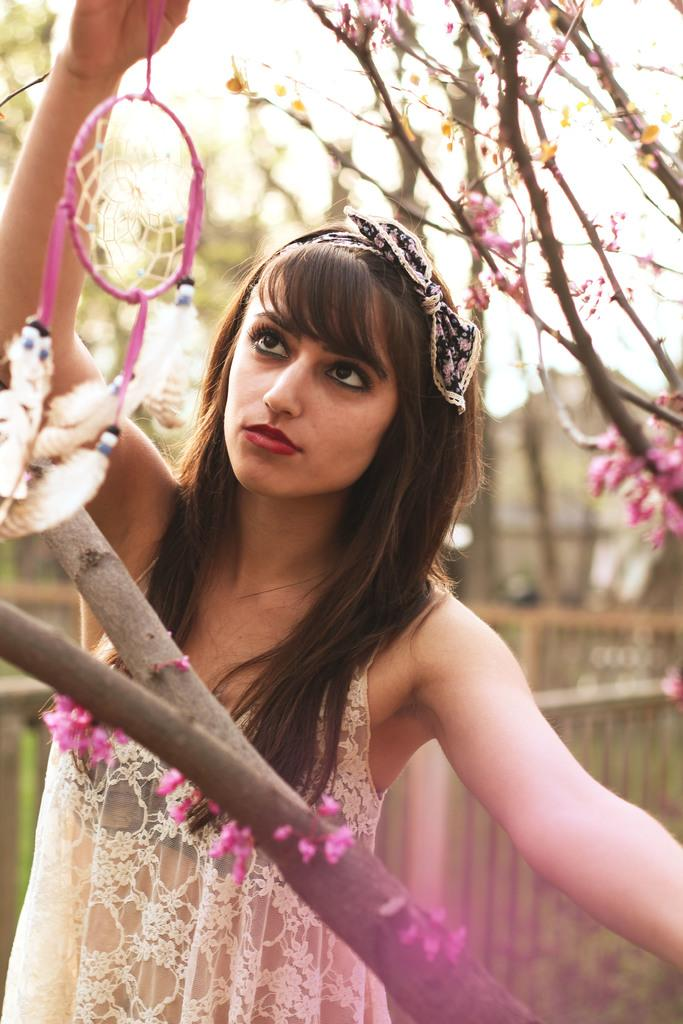Who is the main subject in the image? There is a woman in the image. What is the woman wearing? The woman is wearing a white top. What is the woman holding in the image? The woman is holding an object. What can be seen in the background of the image? There is a branch and a tree with purple flowers in the image. How many cents does the woman have in her pocket in the image? There is no information about the woman having any money or coins in the image, so we cannot determine the number of cents. Is the woman's grandmother also present in the image? The facts provided do not mention any other person, including the woman's grandmother, being present in the image. Are there any roses visible in the image? The facts provided mention a tree with purple flowers, but there is no mention of roses in the image. 